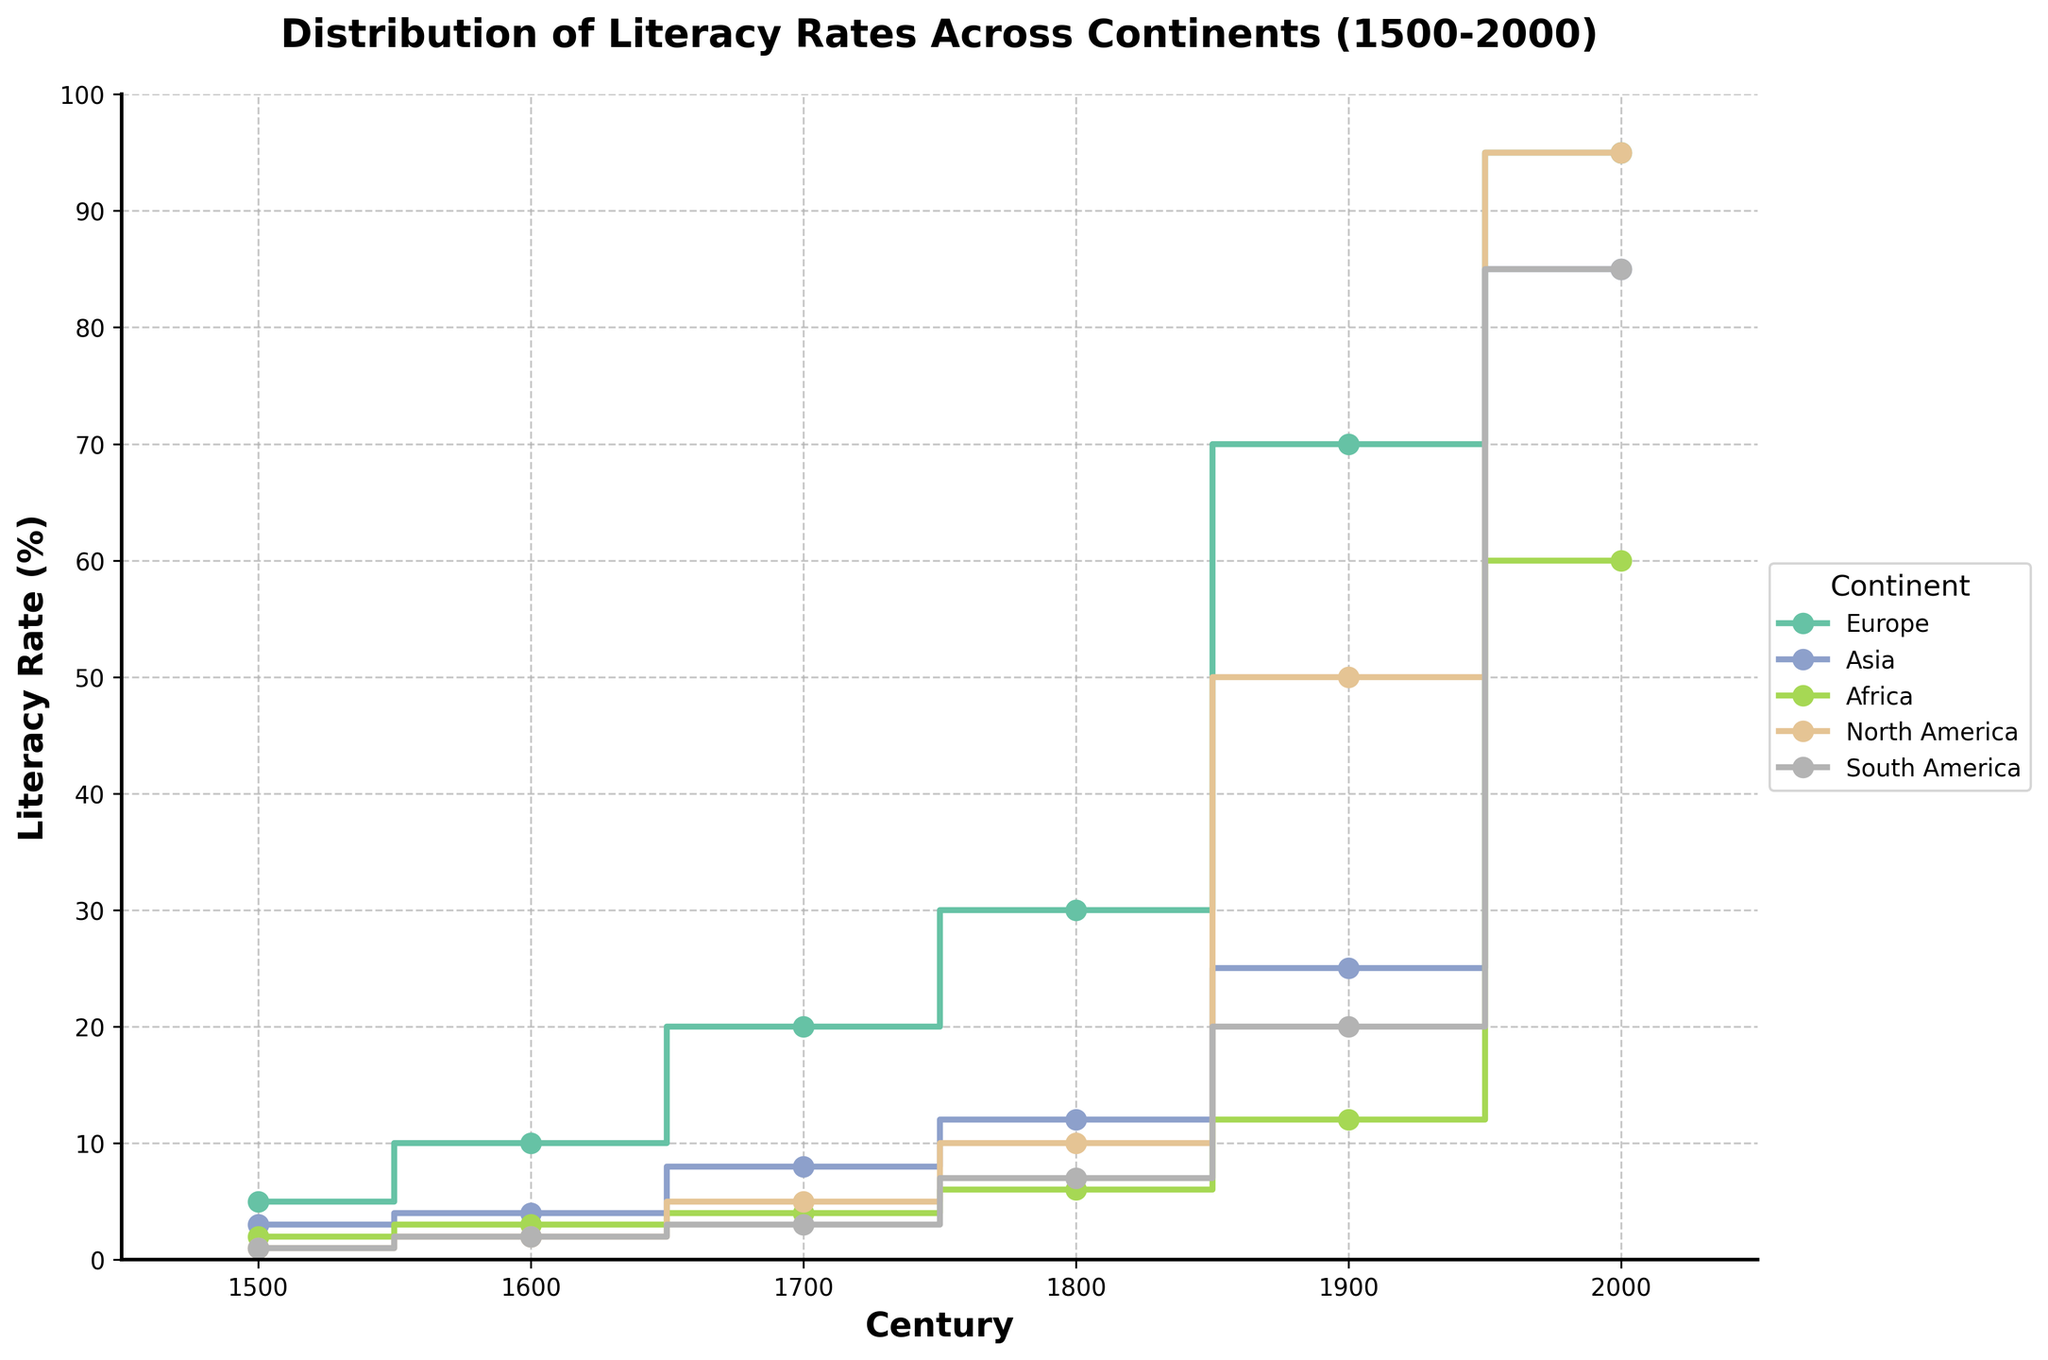What is the title of the figure? The title is written in bold at the top center of the figure. It reads "Distribution of Literacy Rates Across Continents (1500-2000)."
Answer: Distribution of Literacy Rates Across Continents (1500-2000) What is the literacy rate in Europe in the 2000s? The step plot shows the literacy rate for each continent by century. For Europe, it reaches 95% in the 2000s, seen on the rightmost part of the step line for Europe.
Answer: 95% Which continent had the highest literacy rate in the 1700s? The figure depicts step lines for each continent, indicating literacy rates over time. In the 1700s, Europe has the highest literacy rate, which is shown to be 20%.
Answer: Europe What is the trend in literacy rates for Asia from the 1500s to the 2000s? Splitting it century by century, Asia's literacy rates go from 3% in the 1500s to 4% in the 1600s, 8% in the 1700s, 12% in the 1800s, 25% in the 1900s, and finally 85% in the 2000s. Overall, it indicates a consistent upward trend.
Answer: Upward trend How much did Africa's literacy rate increase from the 1500s to the 2000s? Comparing the 1500s rate of 2% with the rate in the 2000s of 60%, the increase is calculated as 60% - 2% = 58%.
Answer: 58% Which continent saw the greatest increase in literacy rate between the 1800s and 1900s? To determine the greatest increase, observe the difference in rates from 1800 to 1900 for each continent. Europe increased by 40% (from 30% to 70%), Asia increased by 13% (from 12% to 25%), Africa increased by 6% (from 6% to 12%), North America by 40% (from 10% to 50%), and South America by 13% (from 7% to 20%). Both Europe and North America saw the greatest increase of 40%.
Answer: Europe and North America What is the literacy rate for South America in the 1900s? On the step plot for South America, follow the corresponding line to the 1900 century mark, which indicates a literacy rate of 20%.
Answer: 20% In which century did North America reach a 50% literacy rate? The step line for North America shows a significant jump to 50% in the 1900s, clearly visible on the plot.
Answer: 1900s Were there any centennial periods where the literacy rate for Europe remained unchanged? By examining the step line for Europe, it doesn't show any plateaus or flat segments throughout, meaning the literacy rate continuously increased without any period of no change.
Answer: No Which two continents had the same literacy rate in the 2000s, and what was it? By looking at the end points for each continent in the 2000s, both Europe and North America match with a literacy rate of 95%.
Answer: Europe and North America, 95% 